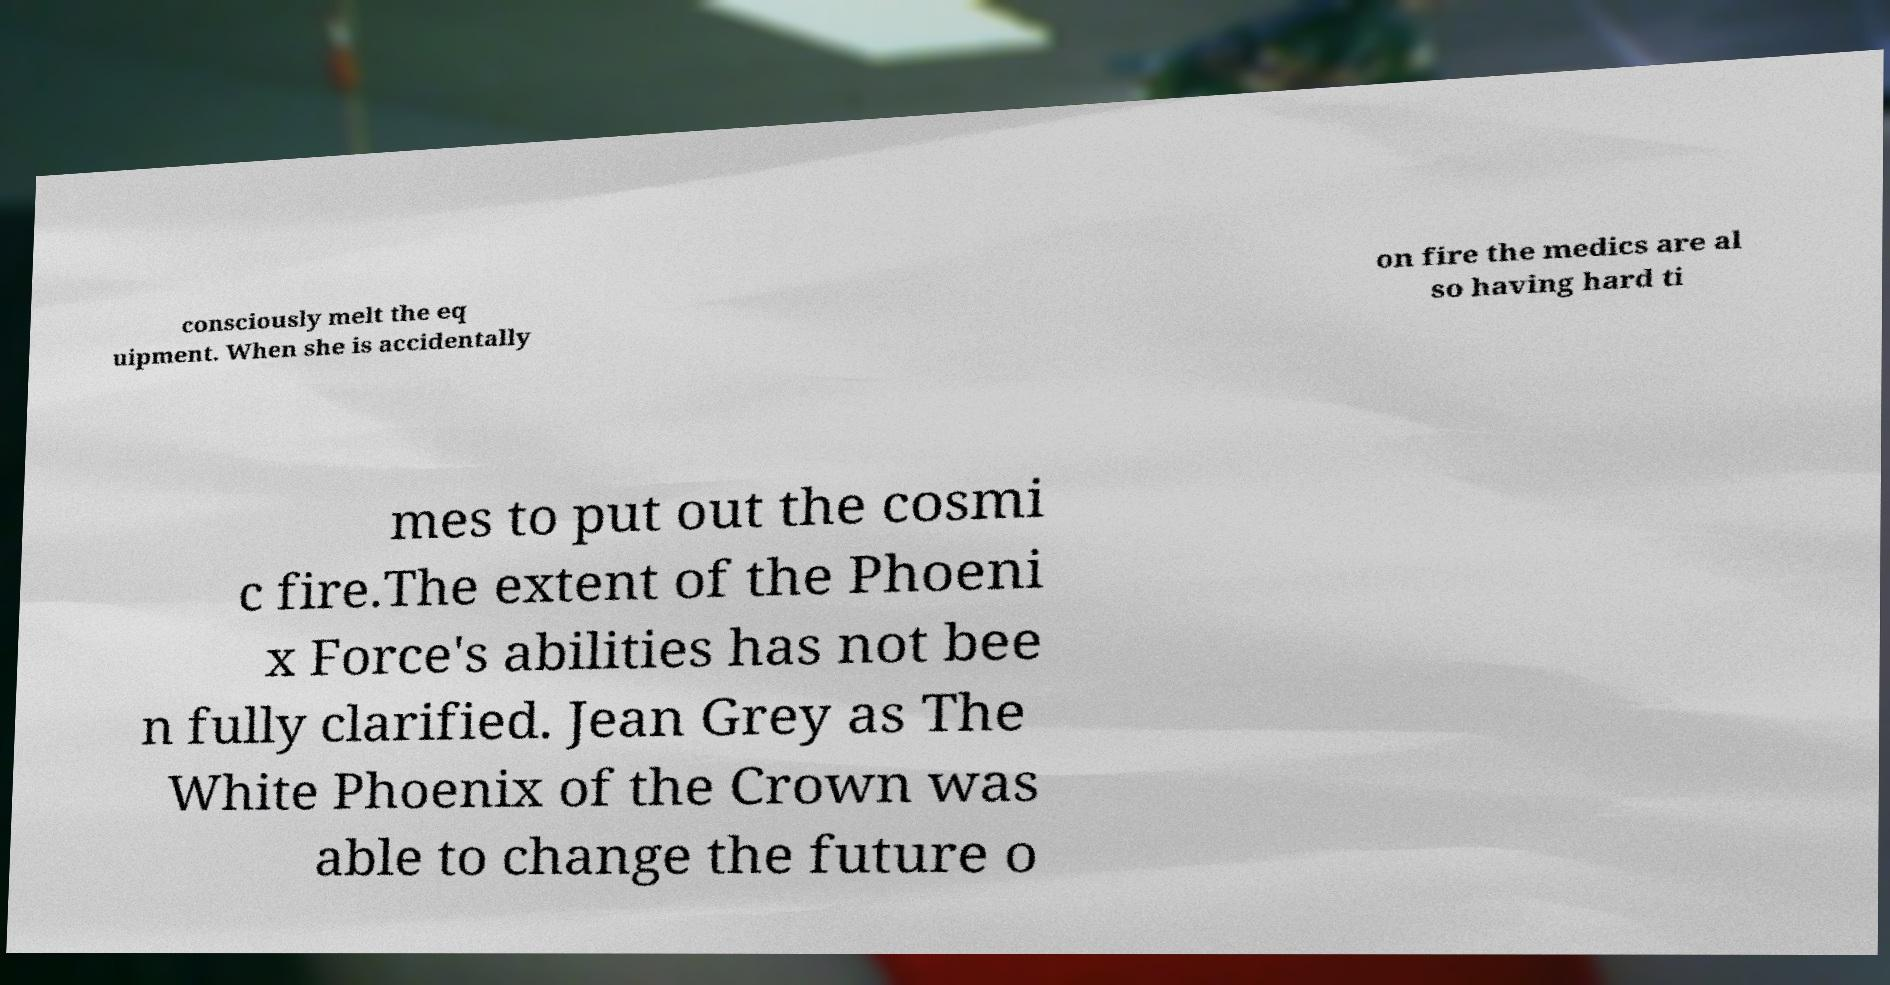There's text embedded in this image that I need extracted. Can you transcribe it verbatim? consciously melt the eq uipment. When she is accidentally on fire the medics are al so having hard ti mes to put out the cosmi c fire.The extent of the Phoeni x Force's abilities has not bee n fully clarified. Jean Grey as The White Phoenix of the Crown was able to change the future o 